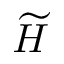<formula> <loc_0><loc_0><loc_500><loc_500>\widetilde { H }</formula> 